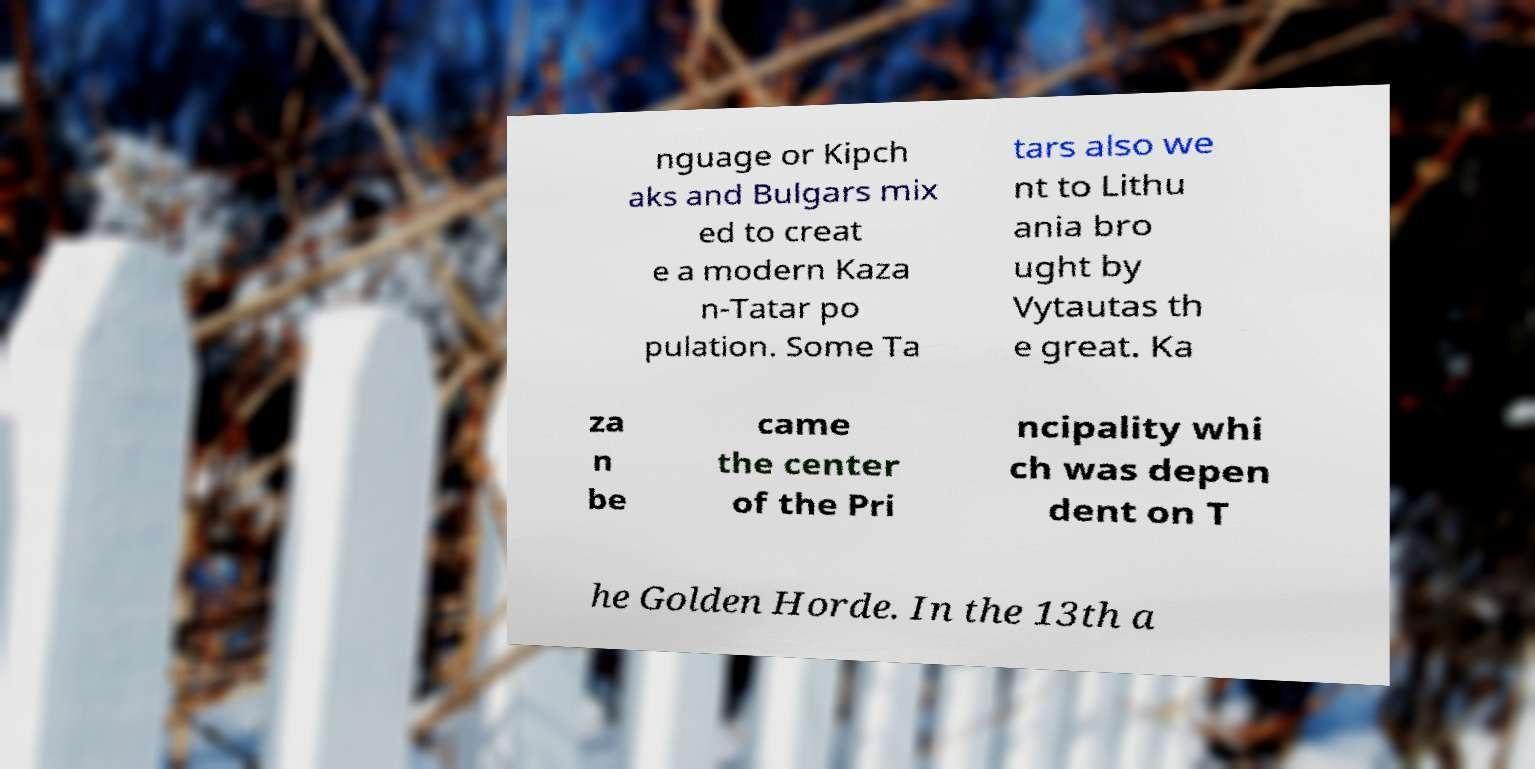For documentation purposes, I need the text within this image transcribed. Could you provide that? nguage or Kipch aks and Bulgars mix ed to creat e a modern Kaza n-Tatar po pulation. Some Ta tars also we nt to Lithu ania bro ught by Vytautas th e great. Ka za n be came the center of the Pri ncipality whi ch was depen dent on T he Golden Horde. In the 13th a 